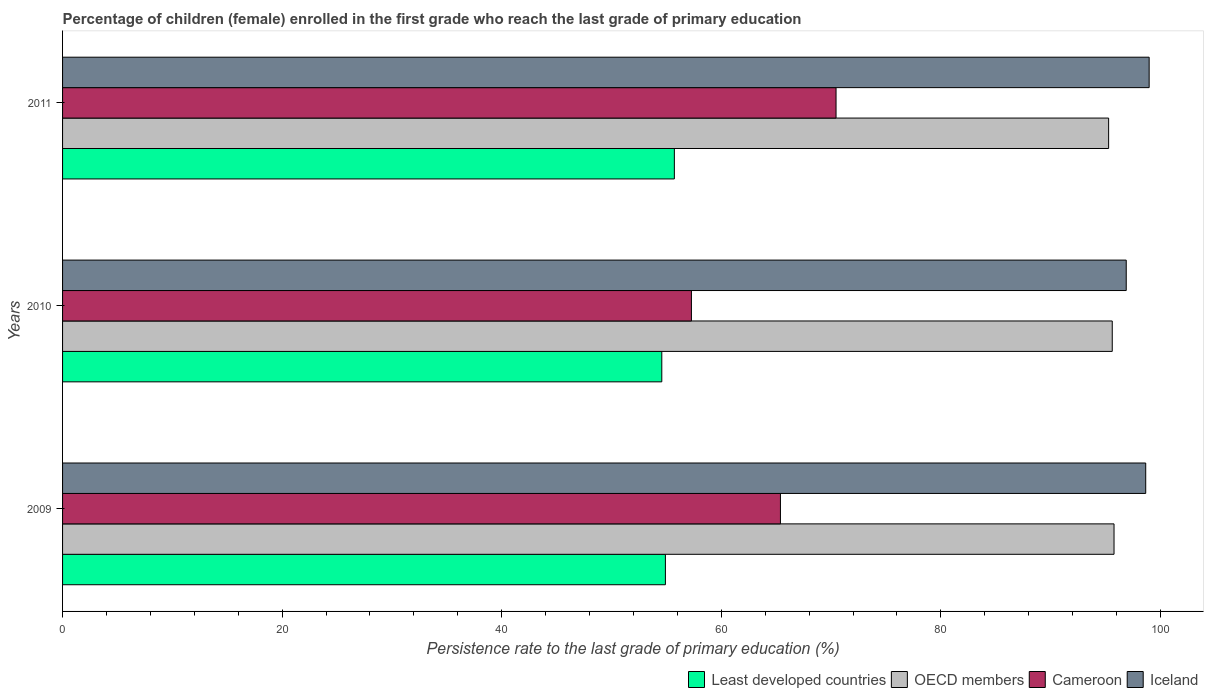How many different coloured bars are there?
Offer a very short reply. 4. How many groups of bars are there?
Your answer should be compact. 3. Are the number of bars per tick equal to the number of legend labels?
Provide a succinct answer. Yes. How many bars are there on the 3rd tick from the top?
Keep it short and to the point. 4. How many bars are there on the 2nd tick from the bottom?
Ensure brevity in your answer.  4. What is the label of the 2nd group of bars from the top?
Your answer should be very brief. 2010. What is the persistence rate of children in Iceland in 2010?
Keep it short and to the point. 96.88. Across all years, what is the maximum persistence rate of children in Least developed countries?
Keep it short and to the point. 55.72. Across all years, what is the minimum persistence rate of children in Iceland?
Your answer should be compact. 96.88. In which year was the persistence rate of children in OECD members maximum?
Provide a succinct answer. 2009. What is the total persistence rate of children in OECD members in the graph?
Provide a succinct answer. 286.65. What is the difference between the persistence rate of children in Iceland in 2009 and that in 2010?
Offer a terse response. 1.77. What is the difference between the persistence rate of children in Iceland in 2010 and the persistence rate of children in Least developed countries in 2011?
Provide a short and direct response. 41.16. What is the average persistence rate of children in Iceland per year?
Offer a terse response. 98.17. In the year 2011, what is the difference between the persistence rate of children in Iceland and persistence rate of children in Least developed countries?
Offer a very short reply. 43.25. In how many years, is the persistence rate of children in Cameroon greater than 28 %?
Offer a terse response. 3. What is the ratio of the persistence rate of children in Iceland in 2009 to that in 2011?
Offer a terse response. 1. Is the difference between the persistence rate of children in Iceland in 2009 and 2011 greater than the difference between the persistence rate of children in Least developed countries in 2009 and 2011?
Give a very brief answer. Yes. What is the difference between the highest and the second highest persistence rate of children in OECD members?
Your answer should be compact. 0.16. What is the difference between the highest and the lowest persistence rate of children in Iceland?
Keep it short and to the point. 2.09. In how many years, is the persistence rate of children in OECD members greater than the average persistence rate of children in OECD members taken over all years?
Give a very brief answer. 2. Is the sum of the persistence rate of children in Cameroon in 2010 and 2011 greater than the maximum persistence rate of children in OECD members across all years?
Your response must be concise. Yes. What does the 4th bar from the top in 2009 represents?
Your response must be concise. Least developed countries. What does the 1st bar from the bottom in 2011 represents?
Ensure brevity in your answer.  Least developed countries. Is it the case that in every year, the sum of the persistence rate of children in Cameroon and persistence rate of children in Least developed countries is greater than the persistence rate of children in Iceland?
Provide a succinct answer. Yes. How many bars are there?
Give a very brief answer. 12. What is the difference between two consecutive major ticks on the X-axis?
Ensure brevity in your answer.  20. Does the graph contain any zero values?
Provide a short and direct response. No. Where does the legend appear in the graph?
Your answer should be compact. Bottom right. How are the legend labels stacked?
Keep it short and to the point. Horizontal. What is the title of the graph?
Offer a terse response. Percentage of children (female) enrolled in the first grade who reach the last grade of primary education. Does "Guyana" appear as one of the legend labels in the graph?
Ensure brevity in your answer.  No. What is the label or title of the X-axis?
Offer a very short reply. Persistence rate to the last grade of primary education (%). What is the Persistence rate to the last grade of primary education (%) of Least developed countries in 2009?
Your answer should be compact. 54.91. What is the Persistence rate to the last grade of primary education (%) of OECD members in 2009?
Ensure brevity in your answer.  95.77. What is the Persistence rate to the last grade of primary education (%) in Cameroon in 2009?
Make the answer very short. 65.38. What is the Persistence rate to the last grade of primary education (%) of Iceland in 2009?
Provide a succinct answer. 98.65. What is the Persistence rate to the last grade of primary education (%) of Least developed countries in 2010?
Give a very brief answer. 54.58. What is the Persistence rate to the last grade of primary education (%) of OECD members in 2010?
Give a very brief answer. 95.61. What is the Persistence rate to the last grade of primary education (%) in Cameroon in 2010?
Make the answer very short. 57.28. What is the Persistence rate to the last grade of primary education (%) of Iceland in 2010?
Your answer should be very brief. 96.88. What is the Persistence rate to the last grade of primary education (%) in Least developed countries in 2011?
Your answer should be very brief. 55.72. What is the Persistence rate to the last grade of primary education (%) of OECD members in 2011?
Your answer should be very brief. 95.28. What is the Persistence rate to the last grade of primary education (%) of Cameroon in 2011?
Provide a short and direct response. 70.45. What is the Persistence rate to the last grade of primary education (%) in Iceland in 2011?
Provide a succinct answer. 98.97. Across all years, what is the maximum Persistence rate to the last grade of primary education (%) of Least developed countries?
Make the answer very short. 55.72. Across all years, what is the maximum Persistence rate to the last grade of primary education (%) of OECD members?
Offer a very short reply. 95.77. Across all years, what is the maximum Persistence rate to the last grade of primary education (%) in Cameroon?
Your answer should be compact. 70.45. Across all years, what is the maximum Persistence rate to the last grade of primary education (%) in Iceland?
Your response must be concise. 98.97. Across all years, what is the minimum Persistence rate to the last grade of primary education (%) in Least developed countries?
Ensure brevity in your answer.  54.58. Across all years, what is the minimum Persistence rate to the last grade of primary education (%) of OECD members?
Offer a very short reply. 95.28. Across all years, what is the minimum Persistence rate to the last grade of primary education (%) of Cameroon?
Offer a terse response. 57.28. Across all years, what is the minimum Persistence rate to the last grade of primary education (%) of Iceland?
Make the answer very short. 96.88. What is the total Persistence rate to the last grade of primary education (%) of Least developed countries in the graph?
Your answer should be very brief. 165.21. What is the total Persistence rate to the last grade of primary education (%) of OECD members in the graph?
Your answer should be very brief. 286.65. What is the total Persistence rate to the last grade of primary education (%) in Cameroon in the graph?
Your response must be concise. 193.11. What is the total Persistence rate to the last grade of primary education (%) of Iceland in the graph?
Give a very brief answer. 294.5. What is the difference between the Persistence rate to the last grade of primary education (%) of Least developed countries in 2009 and that in 2010?
Make the answer very short. 0.33. What is the difference between the Persistence rate to the last grade of primary education (%) in OECD members in 2009 and that in 2010?
Your answer should be very brief. 0.16. What is the difference between the Persistence rate to the last grade of primary education (%) of Cameroon in 2009 and that in 2010?
Offer a terse response. 8.11. What is the difference between the Persistence rate to the last grade of primary education (%) in Iceland in 2009 and that in 2010?
Provide a succinct answer. 1.77. What is the difference between the Persistence rate to the last grade of primary education (%) of Least developed countries in 2009 and that in 2011?
Ensure brevity in your answer.  -0.81. What is the difference between the Persistence rate to the last grade of primary education (%) in OECD members in 2009 and that in 2011?
Provide a short and direct response. 0.49. What is the difference between the Persistence rate to the last grade of primary education (%) in Cameroon in 2009 and that in 2011?
Your answer should be compact. -5.07. What is the difference between the Persistence rate to the last grade of primary education (%) of Iceland in 2009 and that in 2011?
Your answer should be compact. -0.31. What is the difference between the Persistence rate to the last grade of primary education (%) in Least developed countries in 2010 and that in 2011?
Your answer should be compact. -1.14. What is the difference between the Persistence rate to the last grade of primary education (%) of OECD members in 2010 and that in 2011?
Your answer should be very brief. 0.33. What is the difference between the Persistence rate to the last grade of primary education (%) in Cameroon in 2010 and that in 2011?
Ensure brevity in your answer.  -13.17. What is the difference between the Persistence rate to the last grade of primary education (%) of Iceland in 2010 and that in 2011?
Offer a very short reply. -2.09. What is the difference between the Persistence rate to the last grade of primary education (%) of Least developed countries in 2009 and the Persistence rate to the last grade of primary education (%) of OECD members in 2010?
Offer a terse response. -40.7. What is the difference between the Persistence rate to the last grade of primary education (%) of Least developed countries in 2009 and the Persistence rate to the last grade of primary education (%) of Cameroon in 2010?
Keep it short and to the point. -2.37. What is the difference between the Persistence rate to the last grade of primary education (%) of Least developed countries in 2009 and the Persistence rate to the last grade of primary education (%) of Iceland in 2010?
Your response must be concise. -41.97. What is the difference between the Persistence rate to the last grade of primary education (%) in OECD members in 2009 and the Persistence rate to the last grade of primary education (%) in Cameroon in 2010?
Make the answer very short. 38.49. What is the difference between the Persistence rate to the last grade of primary education (%) of OECD members in 2009 and the Persistence rate to the last grade of primary education (%) of Iceland in 2010?
Your answer should be very brief. -1.11. What is the difference between the Persistence rate to the last grade of primary education (%) of Cameroon in 2009 and the Persistence rate to the last grade of primary education (%) of Iceland in 2010?
Your response must be concise. -31.5. What is the difference between the Persistence rate to the last grade of primary education (%) in Least developed countries in 2009 and the Persistence rate to the last grade of primary education (%) in OECD members in 2011?
Offer a very short reply. -40.37. What is the difference between the Persistence rate to the last grade of primary education (%) in Least developed countries in 2009 and the Persistence rate to the last grade of primary education (%) in Cameroon in 2011?
Make the answer very short. -15.54. What is the difference between the Persistence rate to the last grade of primary education (%) of Least developed countries in 2009 and the Persistence rate to the last grade of primary education (%) of Iceland in 2011?
Offer a very short reply. -44.06. What is the difference between the Persistence rate to the last grade of primary education (%) of OECD members in 2009 and the Persistence rate to the last grade of primary education (%) of Cameroon in 2011?
Offer a very short reply. 25.32. What is the difference between the Persistence rate to the last grade of primary education (%) of OECD members in 2009 and the Persistence rate to the last grade of primary education (%) of Iceland in 2011?
Give a very brief answer. -3.2. What is the difference between the Persistence rate to the last grade of primary education (%) of Cameroon in 2009 and the Persistence rate to the last grade of primary education (%) of Iceland in 2011?
Provide a short and direct response. -33.58. What is the difference between the Persistence rate to the last grade of primary education (%) in Least developed countries in 2010 and the Persistence rate to the last grade of primary education (%) in OECD members in 2011?
Offer a terse response. -40.7. What is the difference between the Persistence rate to the last grade of primary education (%) in Least developed countries in 2010 and the Persistence rate to the last grade of primary education (%) in Cameroon in 2011?
Provide a short and direct response. -15.87. What is the difference between the Persistence rate to the last grade of primary education (%) of Least developed countries in 2010 and the Persistence rate to the last grade of primary education (%) of Iceland in 2011?
Provide a succinct answer. -44.39. What is the difference between the Persistence rate to the last grade of primary education (%) of OECD members in 2010 and the Persistence rate to the last grade of primary education (%) of Cameroon in 2011?
Give a very brief answer. 25.16. What is the difference between the Persistence rate to the last grade of primary education (%) of OECD members in 2010 and the Persistence rate to the last grade of primary education (%) of Iceland in 2011?
Offer a very short reply. -3.36. What is the difference between the Persistence rate to the last grade of primary education (%) in Cameroon in 2010 and the Persistence rate to the last grade of primary education (%) in Iceland in 2011?
Your answer should be compact. -41.69. What is the average Persistence rate to the last grade of primary education (%) of Least developed countries per year?
Provide a short and direct response. 55.07. What is the average Persistence rate to the last grade of primary education (%) in OECD members per year?
Your response must be concise. 95.55. What is the average Persistence rate to the last grade of primary education (%) in Cameroon per year?
Make the answer very short. 64.37. What is the average Persistence rate to the last grade of primary education (%) of Iceland per year?
Your answer should be compact. 98.17. In the year 2009, what is the difference between the Persistence rate to the last grade of primary education (%) of Least developed countries and Persistence rate to the last grade of primary education (%) of OECD members?
Your answer should be compact. -40.86. In the year 2009, what is the difference between the Persistence rate to the last grade of primary education (%) in Least developed countries and Persistence rate to the last grade of primary education (%) in Cameroon?
Your answer should be compact. -10.48. In the year 2009, what is the difference between the Persistence rate to the last grade of primary education (%) of Least developed countries and Persistence rate to the last grade of primary education (%) of Iceland?
Offer a terse response. -43.75. In the year 2009, what is the difference between the Persistence rate to the last grade of primary education (%) in OECD members and Persistence rate to the last grade of primary education (%) in Cameroon?
Your answer should be very brief. 30.39. In the year 2009, what is the difference between the Persistence rate to the last grade of primary education (%) of OECD members and Persistence rate to the last grade of primary education (%) of Iceland?
Provide a short and direct response. -2.89. In the year 2009, what is the difference between the Persistence rate to the last grade of primary education (%) in Cameroon and Persistence rate to the last grade of primary education (%) in Iceland?
Give a very brief answer. -33.27. In the year 2010, what is the difference between the Persistence rate to the last grade of primary education (%) of Least developed countries and Persistence rate to the last grade of primary education (%) of OECD members?
Your response must be concise. -41.03. In the year 2010, what is the difference between the Persistence rate to the last grade of primary education (%) of Least developed countries and Persistence rate to the last grade of primary education (%) of Cameroon?
Make the answer very short. -2.7. In the year 2010, what is the difference between the Persistence rate to the last grade of primary education (%) in Least developed countries and Persistence rate to the last grade of primary education (%) in Iceland?
Your response must be concise. -42.3. In the year 2010, what is the difference between the Persistence rate to the last grade of primary education (%) in OECD members and Persistence rate to the last grade of primary education (%) in Cameroon?
Offer a terse response. 38.33. In the year 2010, what is the difference between the Persistence rate to the last grade of primary education (%) in OECD members and Persistence rate to the last grade of primary education (%) in Iceland?
Provide a short and direct response. -1.27. In the year 2010, what is the difference between the Persistence rate to the last grade of primary education (%) of Cameroon and Persistence rate to the last grade of primary education (%) of Iceland?
Offer a very short reply. -39.6. In the year 2011, what is the difference between the Persistence rate to the last grade of primary education (%) in Least developed countries and Persistence rate to the last grade of primary education (%) in OECD members?
Make the answer very short. -39.55. In the year 2011, what is the difference between the Persistence rate to the last grade of primary education (%) of Least developed countries and Persistence rate to the last grade of primary education (%) of Cameroon?
Your response must be concise. -14.73. In the year 2011, what is the difference between the Persistence rate to the last grade of primary education (%) in Least developed countries and Persistence rate to the last grade of primary education (%) in Iceland?
Make the answer very short. -43.25. In the year 2011, what is the difference between the Persistence rate to the last grade of primary education (%) in OECD members and Persistence rate to the last grade of primary education (%) in Cameroon?
Your answer should be compact. 24.83. In the year 2011, what is the difference between the Persistence rate to the last grade of primary education (%) of OECD members and Persistence rate to the last grade of primary education (%) of Iceland?
Ensure brevity in your answer.  -3.69. In the year 2011, what is the difference between the Persistence rate to the last grade of primary education (%) in Cameroon and Persistence rate to the last grade of primary education (%) in Iceland?
Offer a very short reply. -28.52. What is the ratio of the Persistence rate to the last grade of primary education (%) in OECD members in 2009 to that in 2010?
Your response must be concise. 1. What is the ratio of the Persistence rate to the last grade of primary education (%) in Cameroon in 2009 to that in 2010?
Provide a short and direct response. 1.14. What is the ratio of the Persistence rate to the last grade of primary education (%) in Iceland in 2009 to that in 2010?
Your answer should be very brief. 1.02. What is the ratio of the Persistence rate to the last grade of primary education (%) of Least developed countries in 2009 to that in 2011?
Ensure brevity in your answer.  0.99. What is the ratio of the Persistence rate to the last grade of primary education (%) in Cameroon in 2009 to that in 2011?
Provide a succinct answer. 0.93. What is the ratio of the Persistence rate to the last grade of primary education (%) of Least developed countries in 2010 to that in 2011?
Give a very brief answer. 0.98. What is the ratio of the Persistence rate to the last grade of primary education (%) of Cameroon in 2010 to that in 2011?
Offer a very short reply. 0.81. What is the ratio of the Persistence rate to the last grade of primary education (%) in Iceland in 2010 to that in 2011?
Your answer should be compact. 0.98. What is the difference between the highest and the second highest Persistence rate to the last grade of primary education (%) of Least developed countries?
Ensure brevity in your answer.  0.81. What is the difference between the highest and the second highest Persistence rate to the last grade of primary education (%) in OECD members?
Provide a succinct answer. 0.16. What is the difference between the highest and the second highest Persistence rate to the last grade of primary education (%) in Cameroon?
Provide a short and direct response. 5.07. What is the difference between the highest and the second highest Persistence rate to the last grade of primary education (%) of Iceland?
Your answer should be very brief. 0.31. What is the difference between the highest and the lowest Persistence rate to the last grade of primary education (%) of Least developed countries?
Offer a very short reply. 1.14. What is the difference between the highest and the lowest Persistence rate to the last grade of primary education (%) of OECD members?
Offer a terse response. 0.49. What is the difference between the highest and the lowest Persistence rate to the last grade of primary education (%) of Cameroon?
Offer a terse response. 13.17. What is the difference between the highest and the lowest Persistence rate to the last grade of primary education (%) in Iceland?
Offer a terse response. 2.09. 